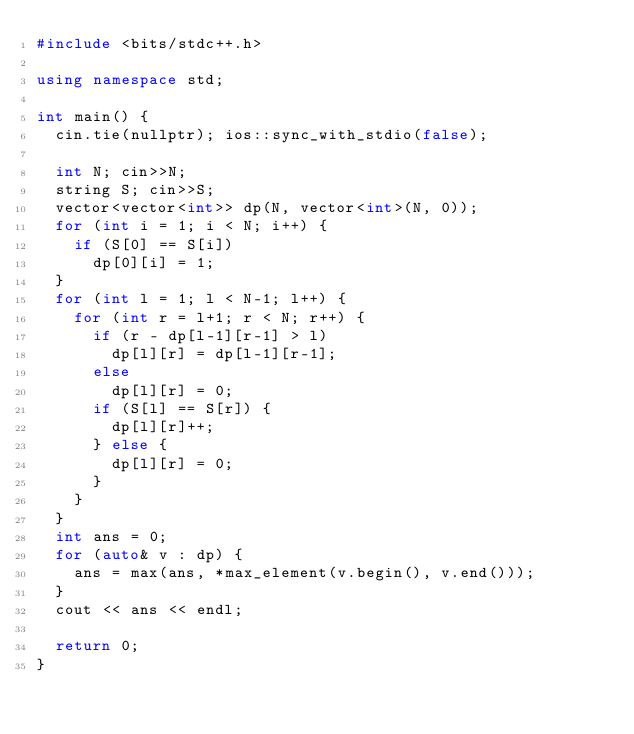Convert code to text. <code><loc_0><loc_0><loc_500><loc_500><_C++_>#include <bits/stdc++.h>

using namespace std;

int main() {
  cin.tie(nullptr); ios::sync_with_stdio(false);

  int N; cin>>N;
  string S; cin>>S;
  vector<vector<int>> dp(N, vector<int>(N, 0));
  for (int i = 1; i < N; i++) {
    if (S[0] == S[i])
      dp[0][i] = 1;
  }
  for (int l = 1; l < N-1; l++) {
    for (int r = l+1; r < N; r++) {
      if (r - dp[l-1][r-1] > l)
        dp[l][r] = dp[l-1][r-1];
      else
        dp[l][r] = 0;
      if (S[l] == S[r]) {
        dp[l][r]++;
      } else {
        dp[l][r] = 0;
      }
    }
  }
  int ans = 0;
  for (auto& v : dp) {
    ans = max(ans, *max_element(v.begin(), v.end()));
  }
  cout << ans << endl;

  return 0;
}
</code> 